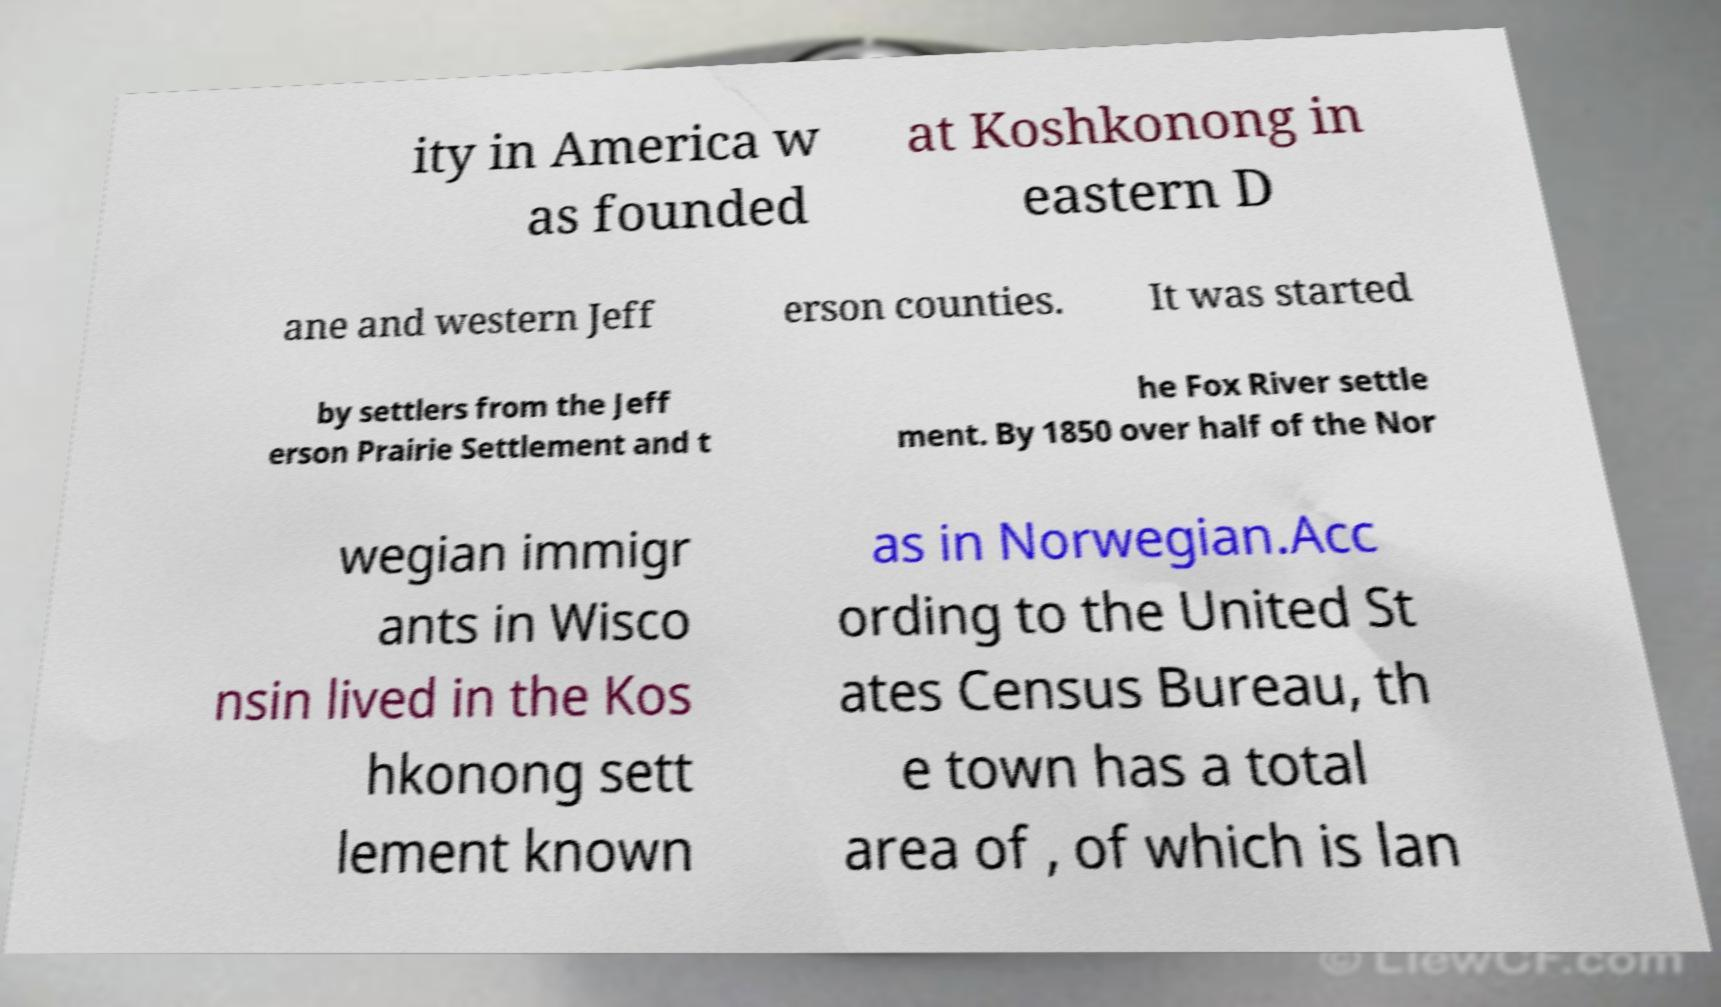Can you read and provide the text displayed in the image?This photo seems to have some interesting text. Can you extract and type it out for me? ity in America w as founded at Koshkonong in eastern D ane and western Jeff erson counties. It was started by settlers from the Jeff erson Prairie Settlement and t he Fox River settle ment. By 1850 over half of the Nor wegian immigr ants in Wisco nsin lived in the Kos hkonong sett lement known as in Norwegian.Acc ording to the United St ates Census Bureau, th e town has a total area of , of which is lan 